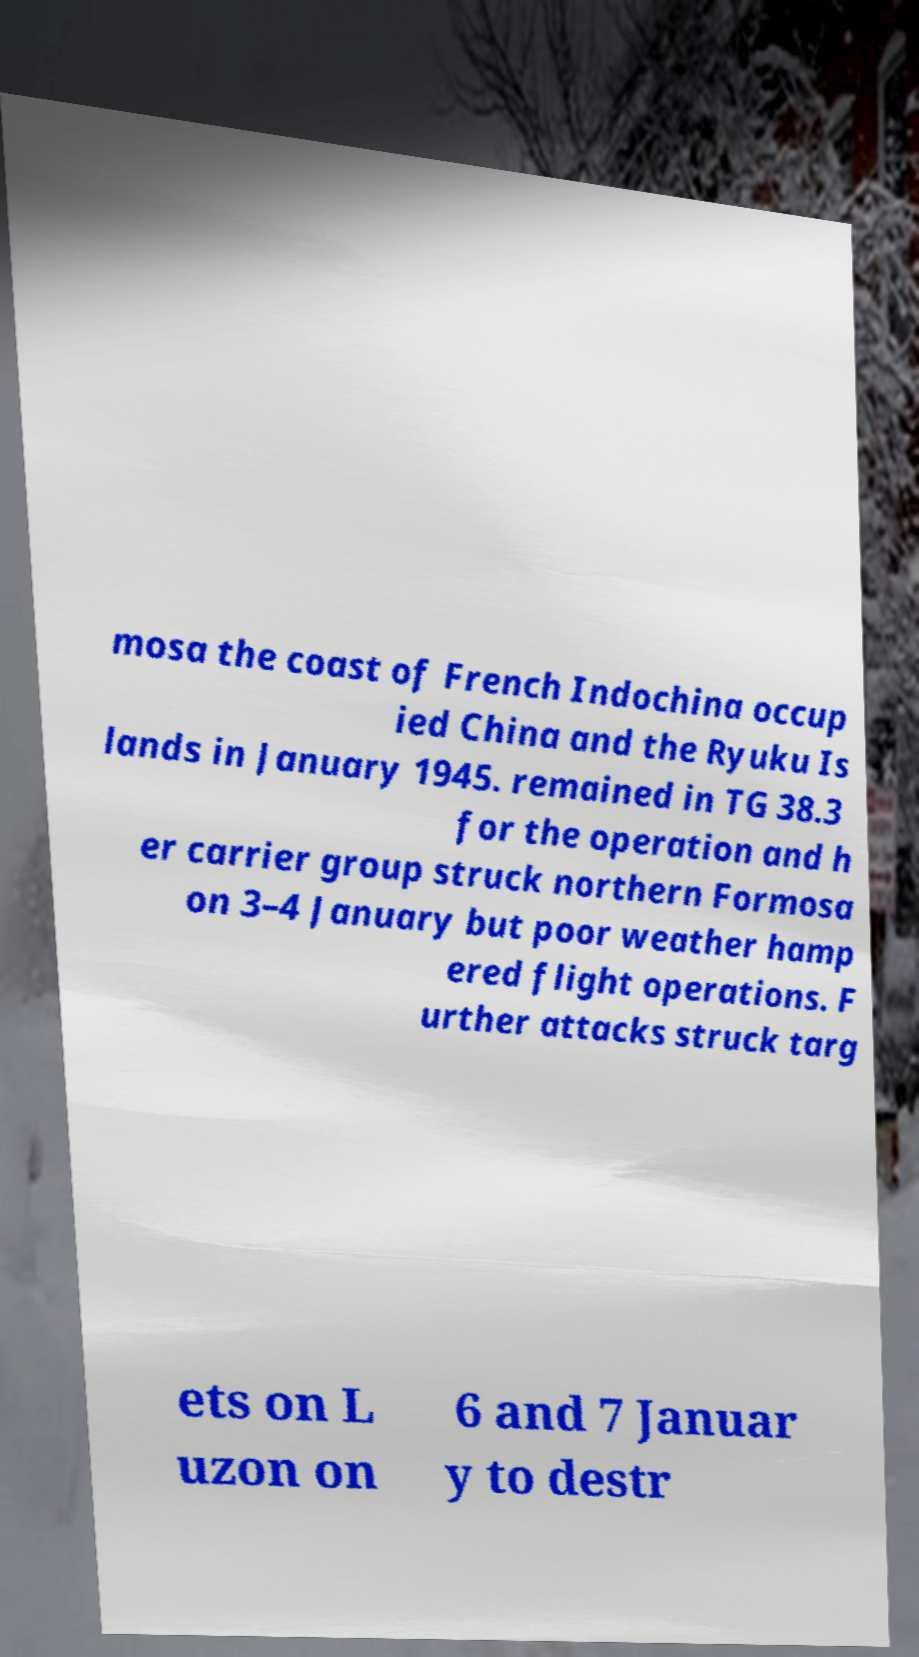I need the written content from this picture converted into text. Can you do that? mosa the coast of French Indochina occup ied China and the Ryuku Is lands in January 1945. remained in TG 38.3 for the operation and h er carrier group struck northern Formosa on 3–4 January but poor weather hamp ered flight operations. F urther attacks struck targ ets on L uzon on 6 and 7 Januar y to destr 